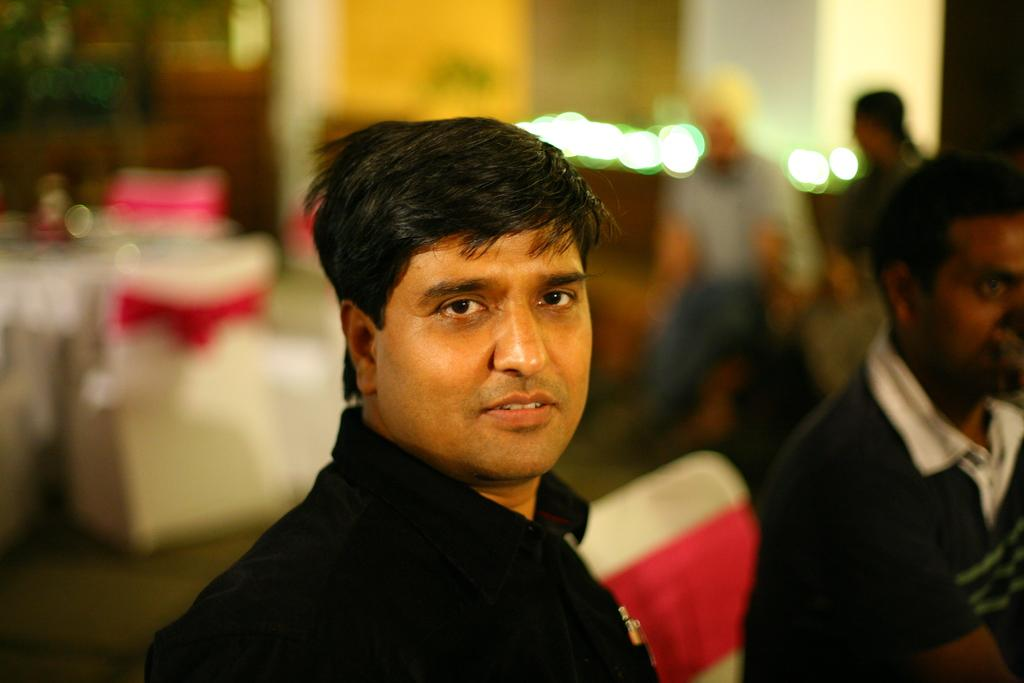Who is present in the image? There is a man in the image. What furniture is visible in the image? There is a table and chairs in the image. How are the chairs decorated? The chairs are decorated with cloth. What are the people in the chairs doing? There are people sitting in the chairs. What can be seen in the background of the image? There is a wall visible in the image. Can you see a yam being cooked on the table in the image? There is no yam or cooking activity present in the image. Is there an airplane taking off from the wall in the image? There is no airplane or any flying object present in the image. 